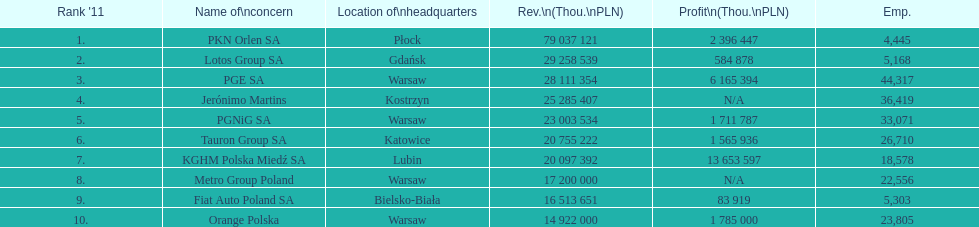Which company had the most employees? PGE SA. 